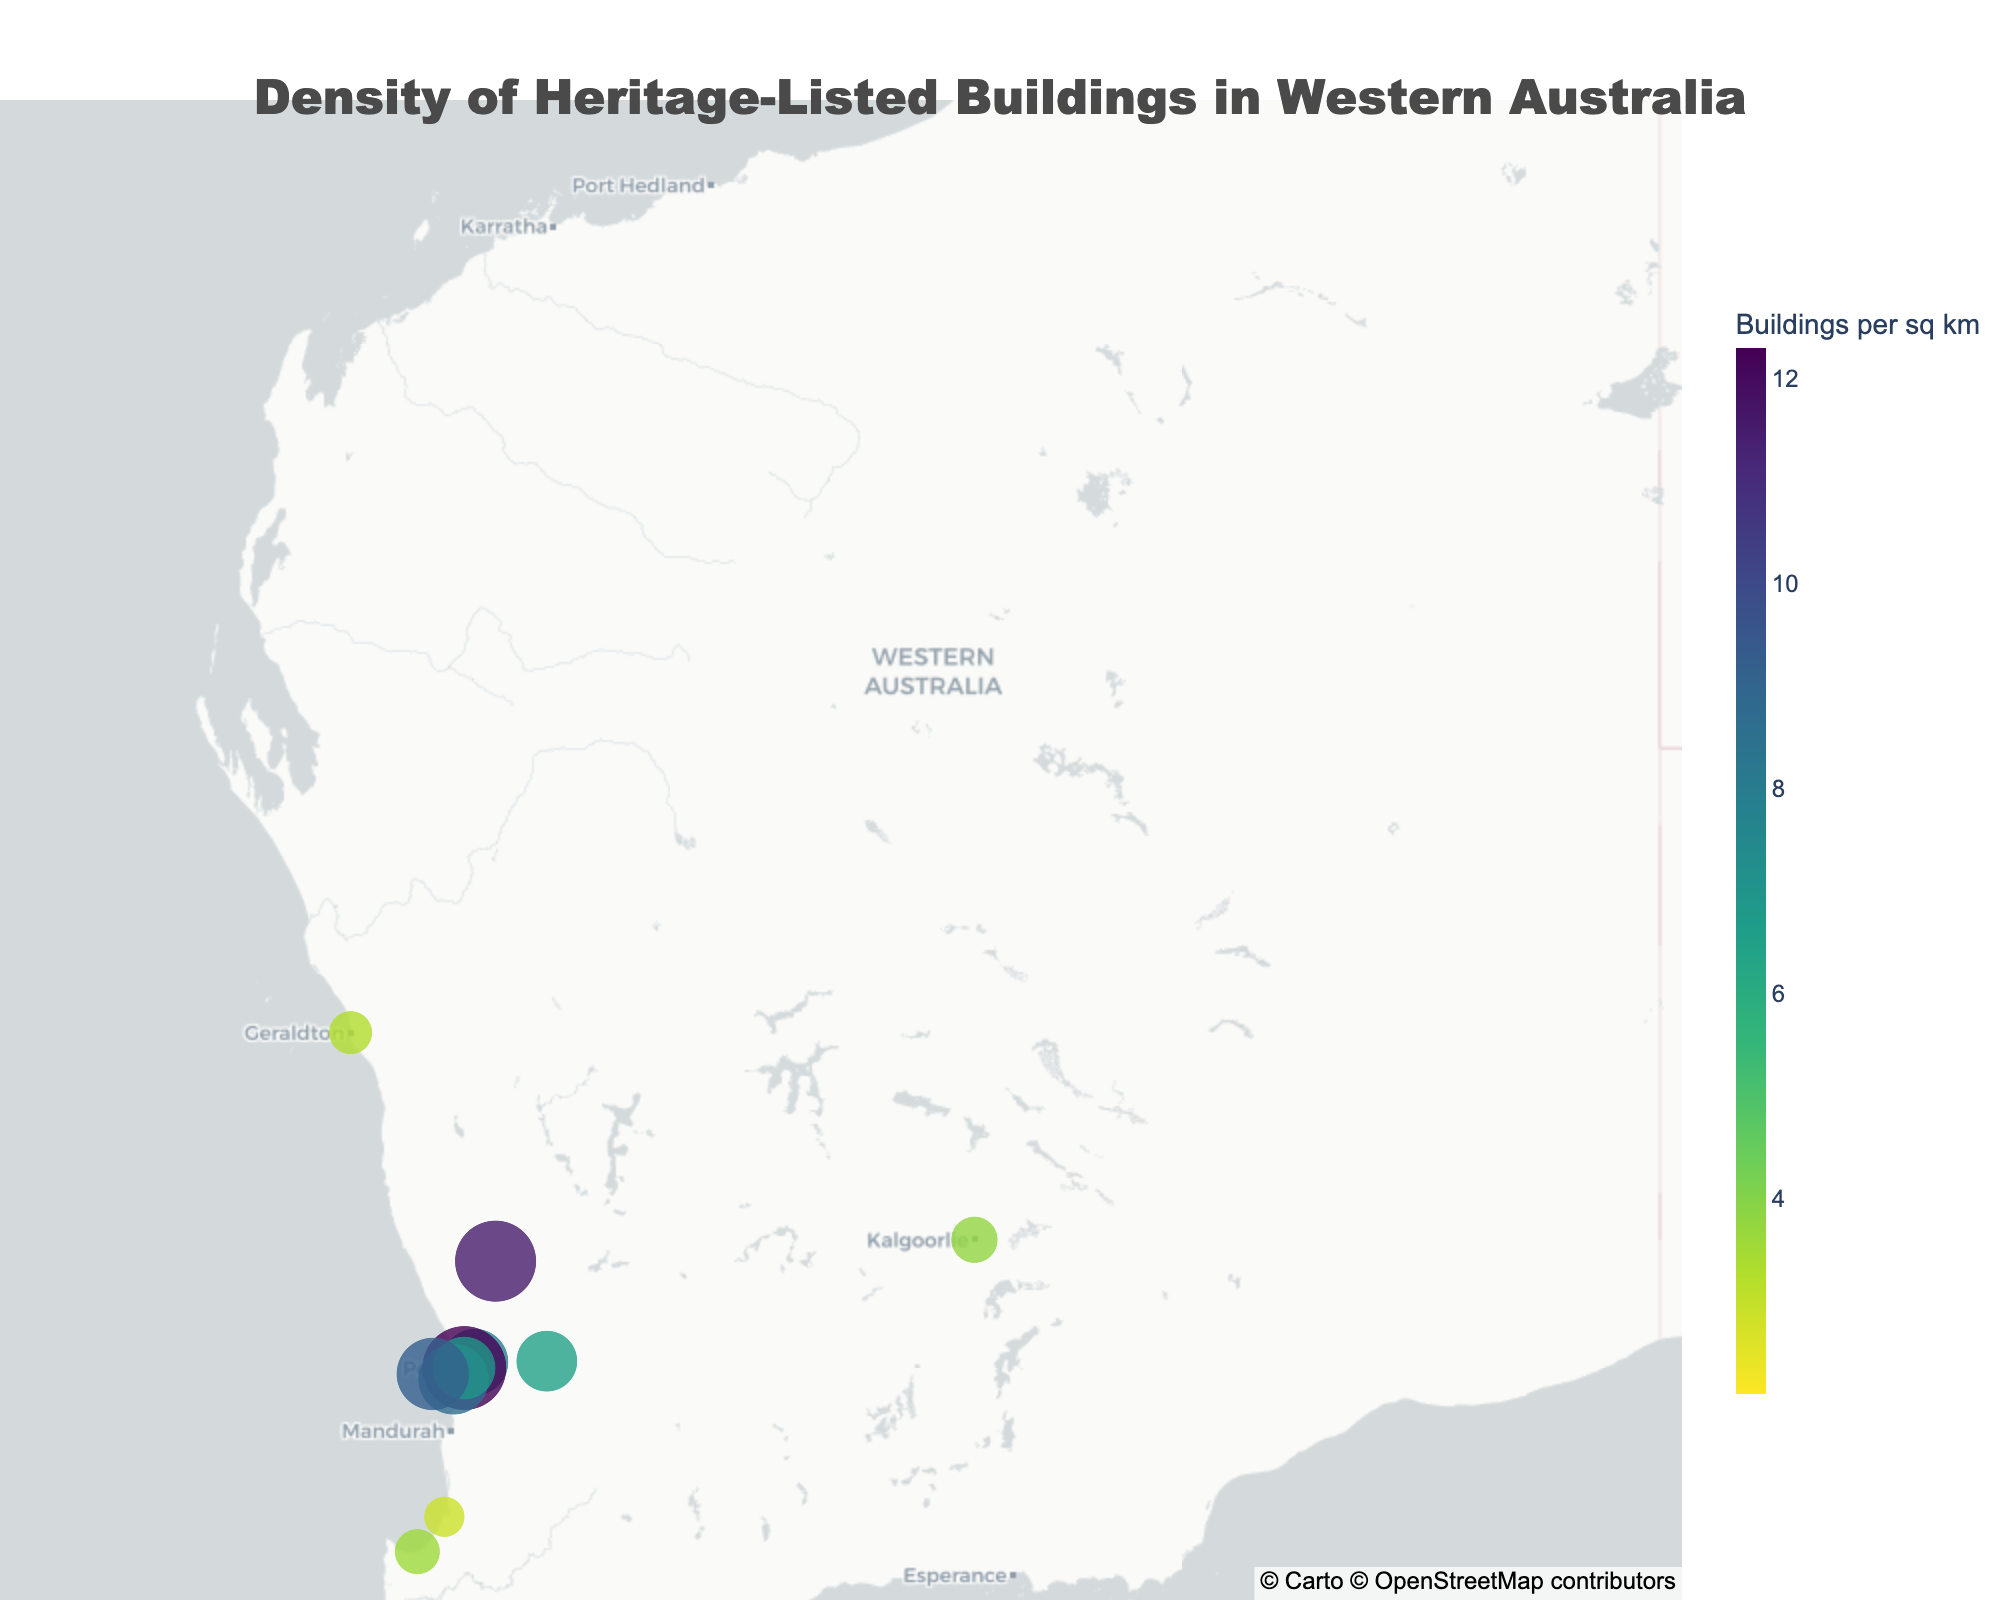what is the title of this figure? The title of the figure is located at the top and is designed to provide an immediate understanding of what the visual represents.
Answer: Density of Heritage-Listed Buildings in Western Australia Which region has the highest density of heritage-listed buildings? Locate the data points on the map and identify the one with the largest size. The region with the highest value is highlighted accordingly in the figure.
Answer: Perth CBD Which region has the lowest density of heritage-listed buildings? Identify the smallest data point on the map. The region with the lowest value appears as a smaller circle compared to others.
Answer: Broome How many regions have a density of heritage-listed buildings greater than 7 buildings per square kilometer? Count all the circles representing regions with values exceeding 7. This requires identifying and summing up all relevant data points visually from the map.
Answer: 6 What is the average density of heritage-listed buildings for Perth CBD and Fremantle? Add the densities for these two regions and divide by 2. Perth CBD has 12.3 buildings per sq km and Fremantle has 8.7 buildings per sq km. (12.3 + 8.7) / 2 = 10.5
Answer: 10.5 How does the density of heritage-listed buildings in Rottnest Island compare to New Norcia? Compare the values directly from the map representation. Rottnest Island has 9.2 buildings per sq km, and New Norcia has 11.5 buildings per sq km.
Answer: Rottnest Island has a lower density than New Norcia Which regions have a density close to the average value among all listed regions? Calculate the average density and identify regions with values close to this average. Sum all densities and divide by the number of regions. Average is (12.3 + 8.7 + 5.2 + 6.9 + 7.8 + 4.1 + 6.5 + 3.8 + 2.9 + 3.3 + 2.1 + 3.6 + 9.2 + 11.5) / 14 = ~6.5
Answer: York Which two regions have the closest densities of heritage-listed buildings per square kilometer, and what is that density difference? Compare the densities and identify the two that are closest. Fremantle (8.7) and Guildford (7.8) have the smallest difference. Density difference is 8.7 - 7.8 = 0.9
Answer: Fremantle and Guildford; 0.9 What geographic area does the figure focus on based on the map view? Look at the center coordinates, map zoom level, and the areas highlighted by the circles. The entire figure is focused on a specific region with notable landmarks.
Answer: Western Australia How many data points are shown on the map? Count each circle representing a different region on the map. Each point corresponds to the density of heritage-listed buildings within the given area.
Answer: 14 